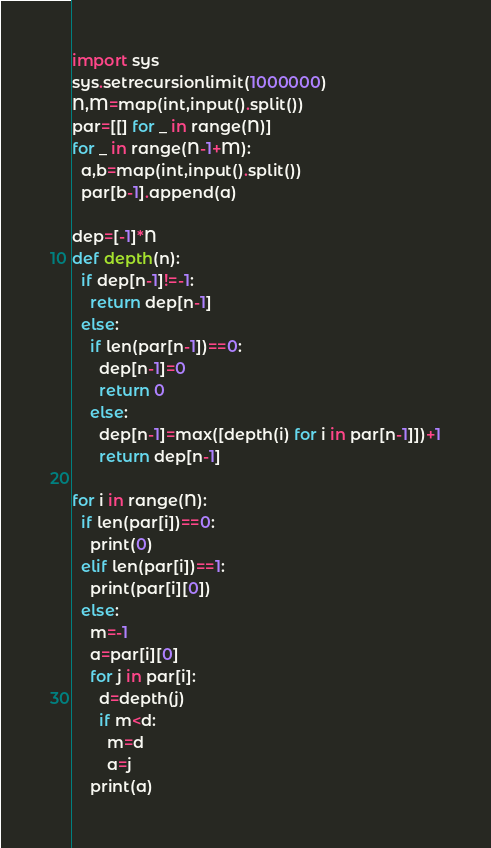Convert code to text. <code><loc_0><loc_0><loc_500><loc_500><_Python_>import sys
sys.setrecursionlimit(1000000)
N,M=map(int,input().split())
par=[[] for _ in range(N)]
for _ in range(N-1+M):
  a,b=map(int,input().split())
  par[b-1].append(a)

dep=[-1]*N
def depth(n):
  if dep[n-1]!=-1:
    return dep[n-1]
  else:
    if len(par[n-1])==0:
      dep[n-1]=0
      return 0
    else:
      dep[n-1]=max([depth(i) for i in par[n-1]])+1
      return dep[n-1]

for i in range(N):
  if len(par[i])==0:
    print(0)
  elif len(par[i])==1:
    print(par[i][0])
  else:
    m=-1
    a=par[i][0]
    for j in par[i]:
      d=depth(j)
      if m<d:
        m=d
        a=j
    print(a)</code> 